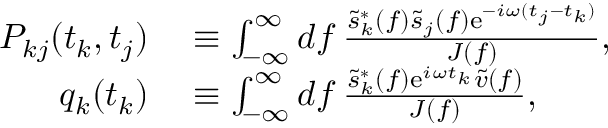Convert formula to latex. <formula><loc_0><loc_0><loc_500><loc_500>\begin{array} { r l } { P _ { k j } ( t _ { k } , t _ { j } ) } & \equiv \int _ { - \infty } ^ { \infty } d f \frac { \tilde { s } _ { k } ^ { * } ( f ) \tilde { s } _ { j } ( f ) e ^ { - i \omega ( t _ { j } - t _ { k } ) } } { J ( f ) } , } \\ { q _ { k } ( t _ { k } ) } & \equiv \int _ { - \infty } ^ { \infty } d f \frac { \tilde { s } _ { k } ^ { * } ( f ) e ^ { i \omega t _ { k } } \tilde { v } ( f ) } { J ( f ) } , } \end{array}</formula> 